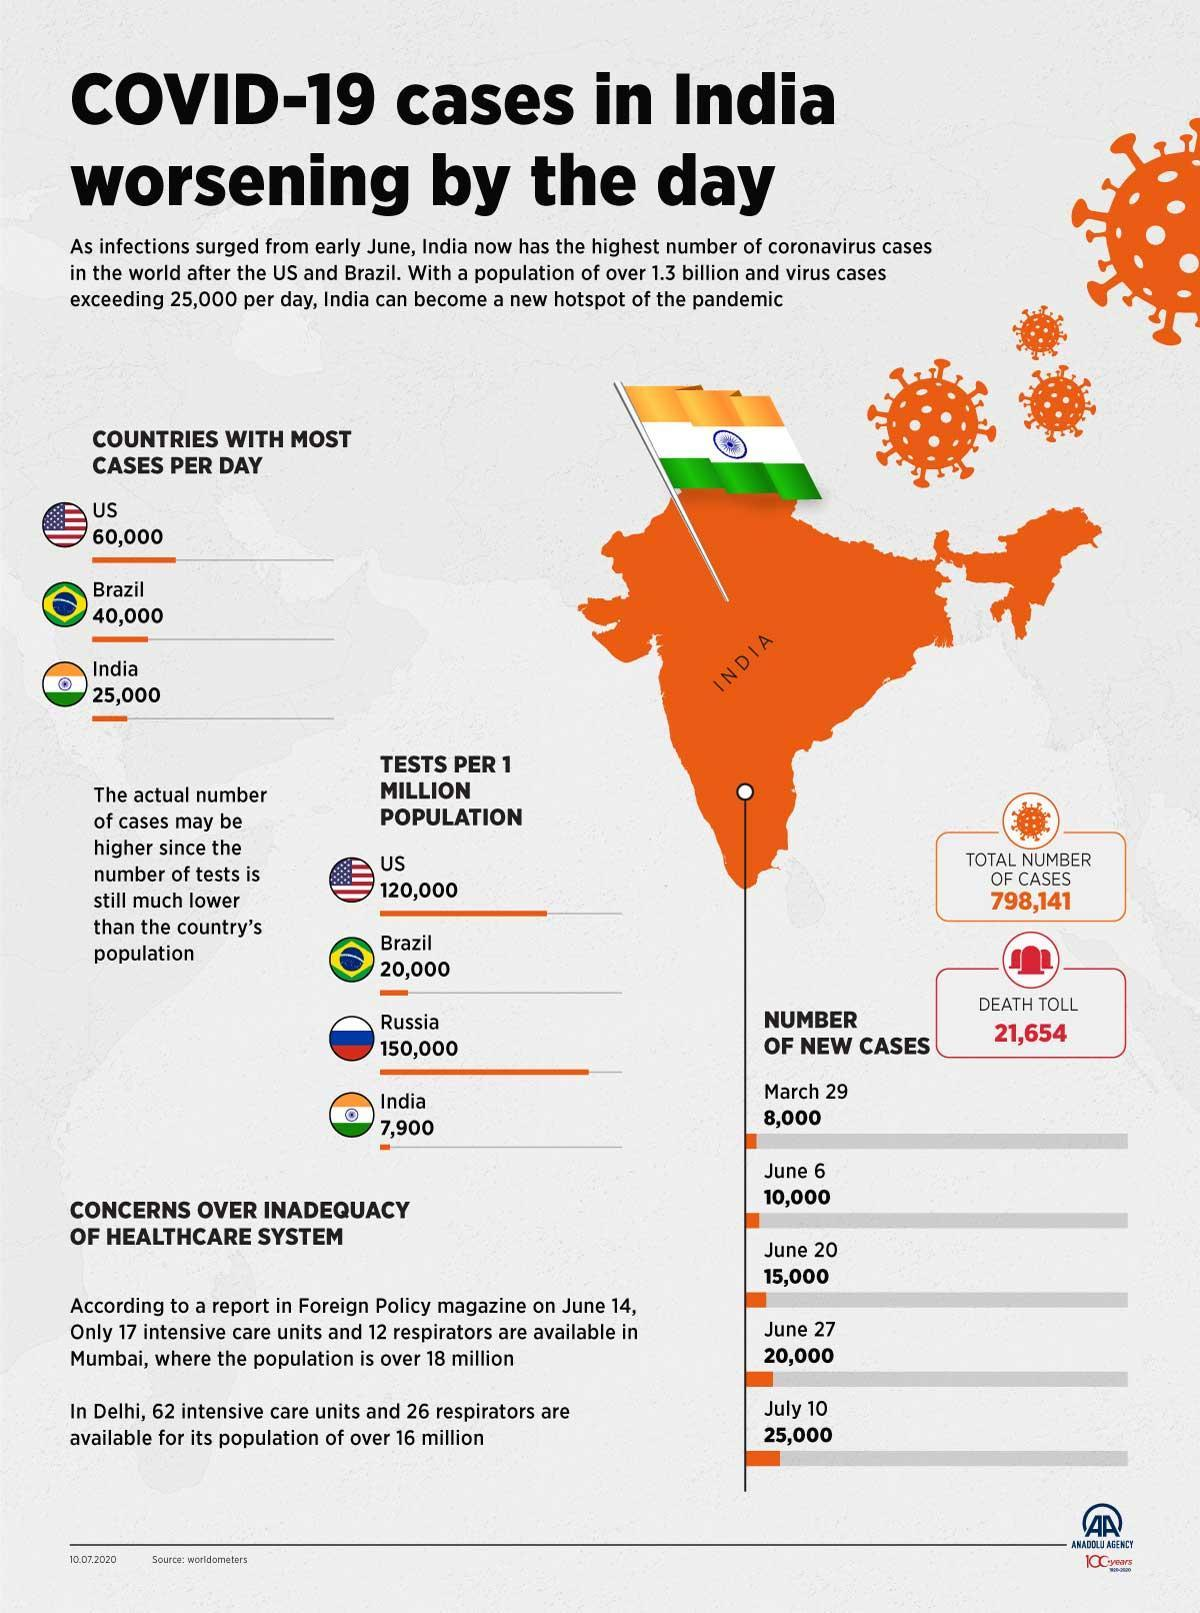By what number is the tests per 1 million population in India lower than that in the US?
Answer the question with a short phrase. 1,12,100 By what number did the cases in India increase from March 29 to July 10? 17,000 What is the difference in cases per day between US and Brazil? 20,000 How many people did not survive Covid? 21,654 